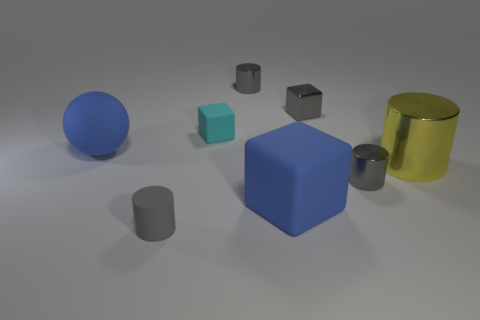Are there fewer large metallic cylinders than small cyan matte cylinders? There is an equal number of large metallic cylinders and small cyan matte cylinders, which is one each. Both objects are positioned separately, and their distinct sizes and textures can be clearly observed. 